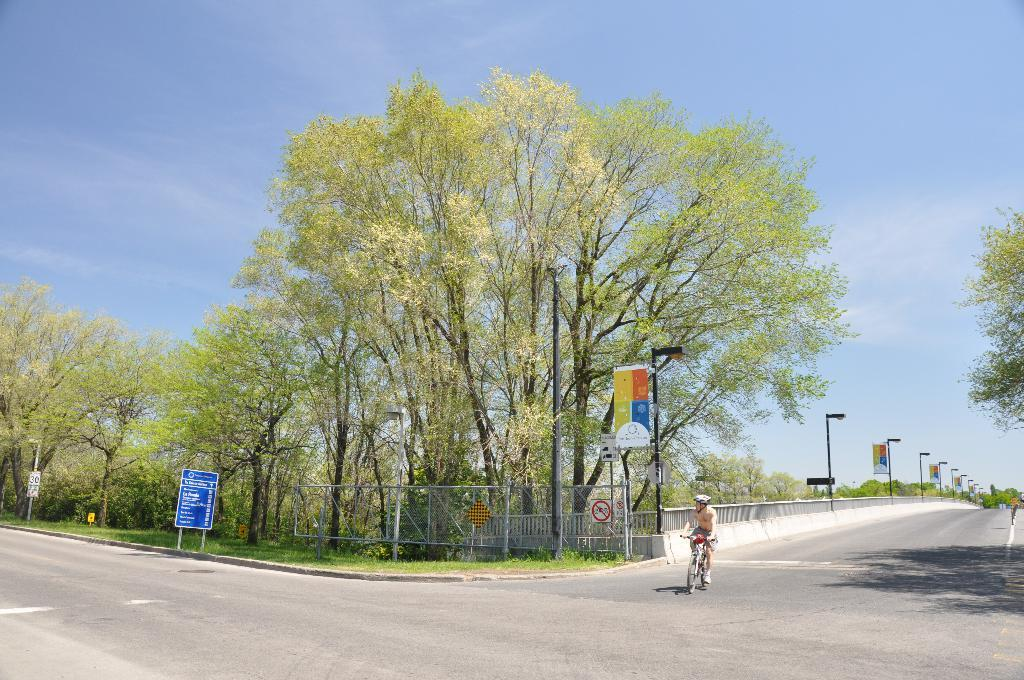What is the person in the image doing? There is a person riding a bicycle on the road in the image. What objects can be seen in the image besides the person and the bicycle? There are poles, boards, grass, a fence, trees, and the sky visible in the image. Can you describe the terrain in the image? The terrain includes grass and trees, suggesting a natural setting. What is the purpose of the poles in the image? The purpose of the poles in the image cannot be determined from the facts provided. What degree of difficulty is the person riding the bicycle experiencing in the image? There is no information provided about the degree of difficulty the person is experiencing while riding the bicycle. 